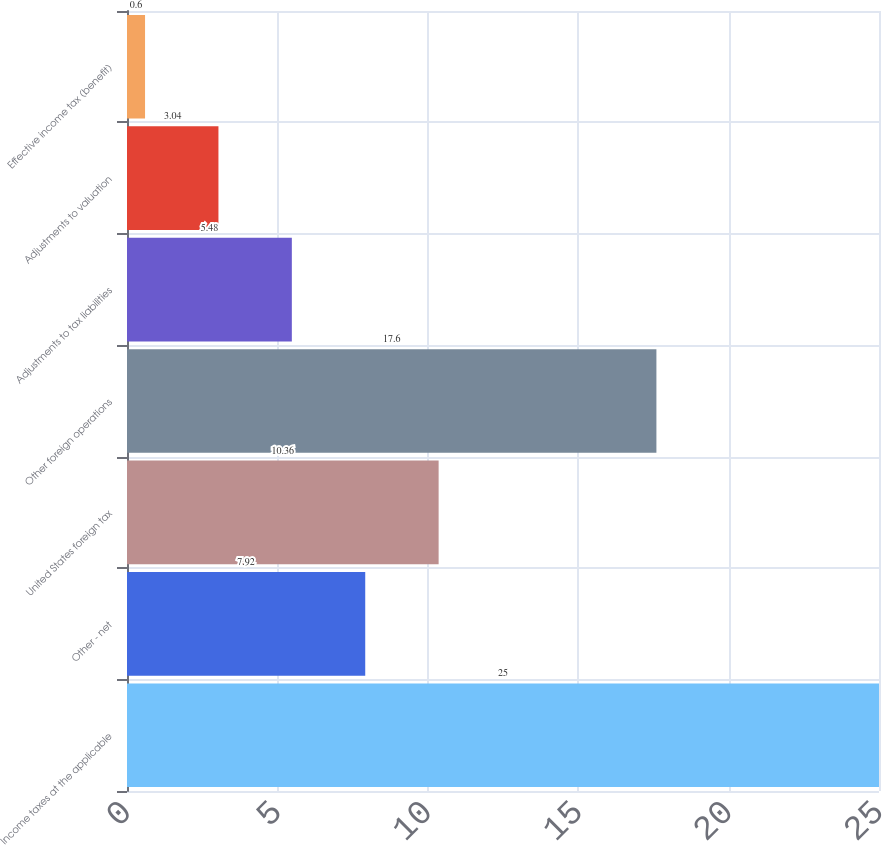Convert chart to OTSL. <chart><loc_0><loc_0><loc_500><loc_500><bar_chart><fcel>Income taxes at the applicable<fcel>Other - net<fcel>United States foreign tax<fcel>Other foreign operations<fcel>Adjustments to tax liabilities<fcel>Adjustments to valuation<fcel>Effective income tax (benefit)<nl><fcel>25<fcel>7.92<fcel>10.36<fcel>17.6<fcel>5.48<fcel>3.04<fcel>0.6<nl></chart> 